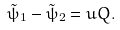<formula> <loc_0><loc_0><loc_500><loc_500>\tilde { \psi } _ { 1 } - \tilde { \psi } _ { 2 } = u Q .</formula> 